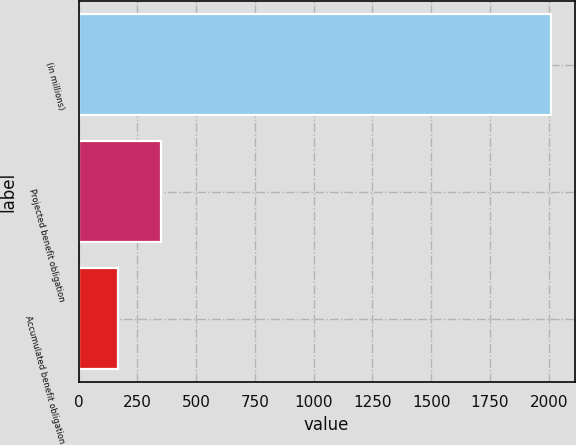Convert chart to OTSL. <chart><loc_0><loc_0><loc_500><loc_500><bar_chart><fcel>(in millions)<fcel>Projected benefit obligation<fcel>Accumulated benefit obligation<nl><fcel>2010<fcel>351.3<fcel>167<nl></chart> 